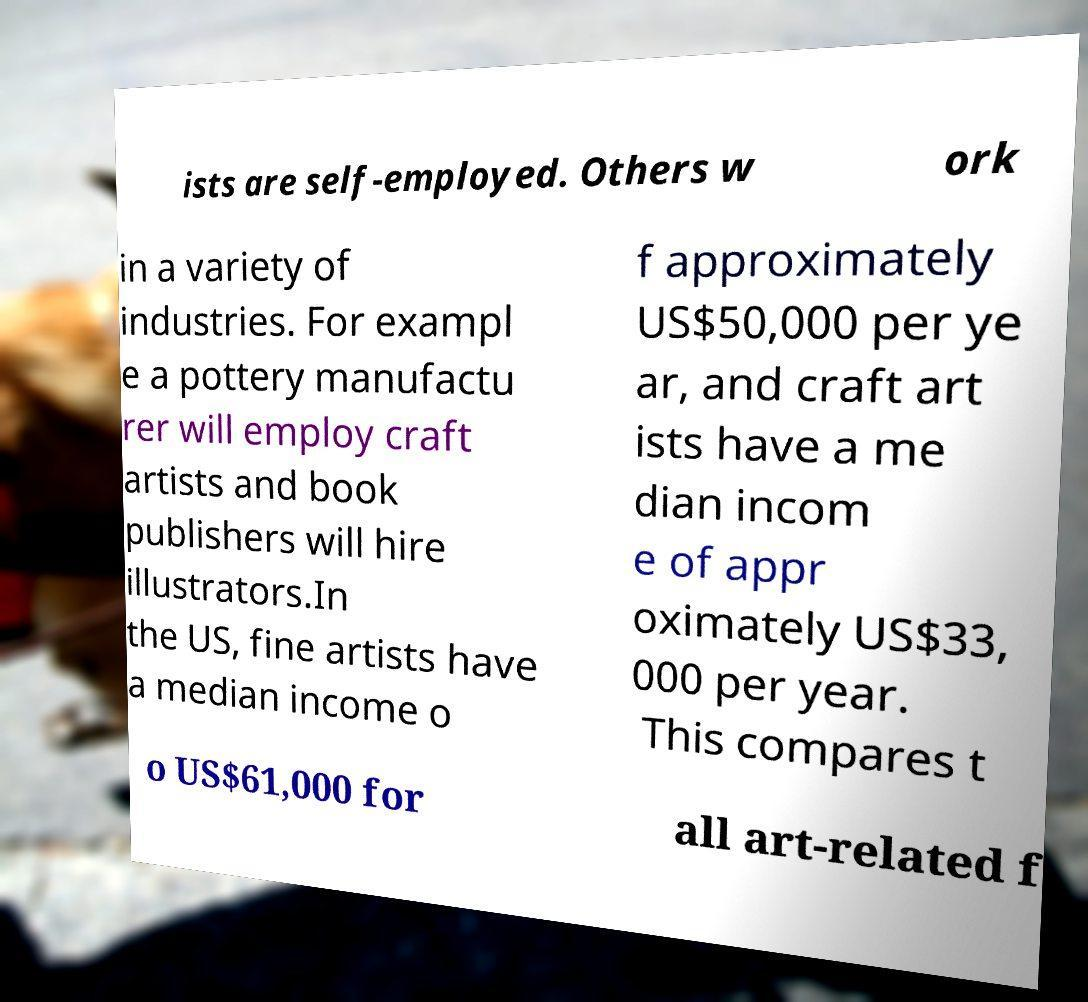Can you accurately transcribe the text from the provided image for me? ists are self-employed. Others w ork in a variety of industries. For exampl e a pottery manufactu rer will employ craft artists and book publishers will hire illustrators.In the US, fine artists have a median income o f approximately US$50,000 per ye ar, and craft art ists have a me dian incom e of appr oximately US$33, 000 per year. This compares t o US$61,000 for all art-related f 